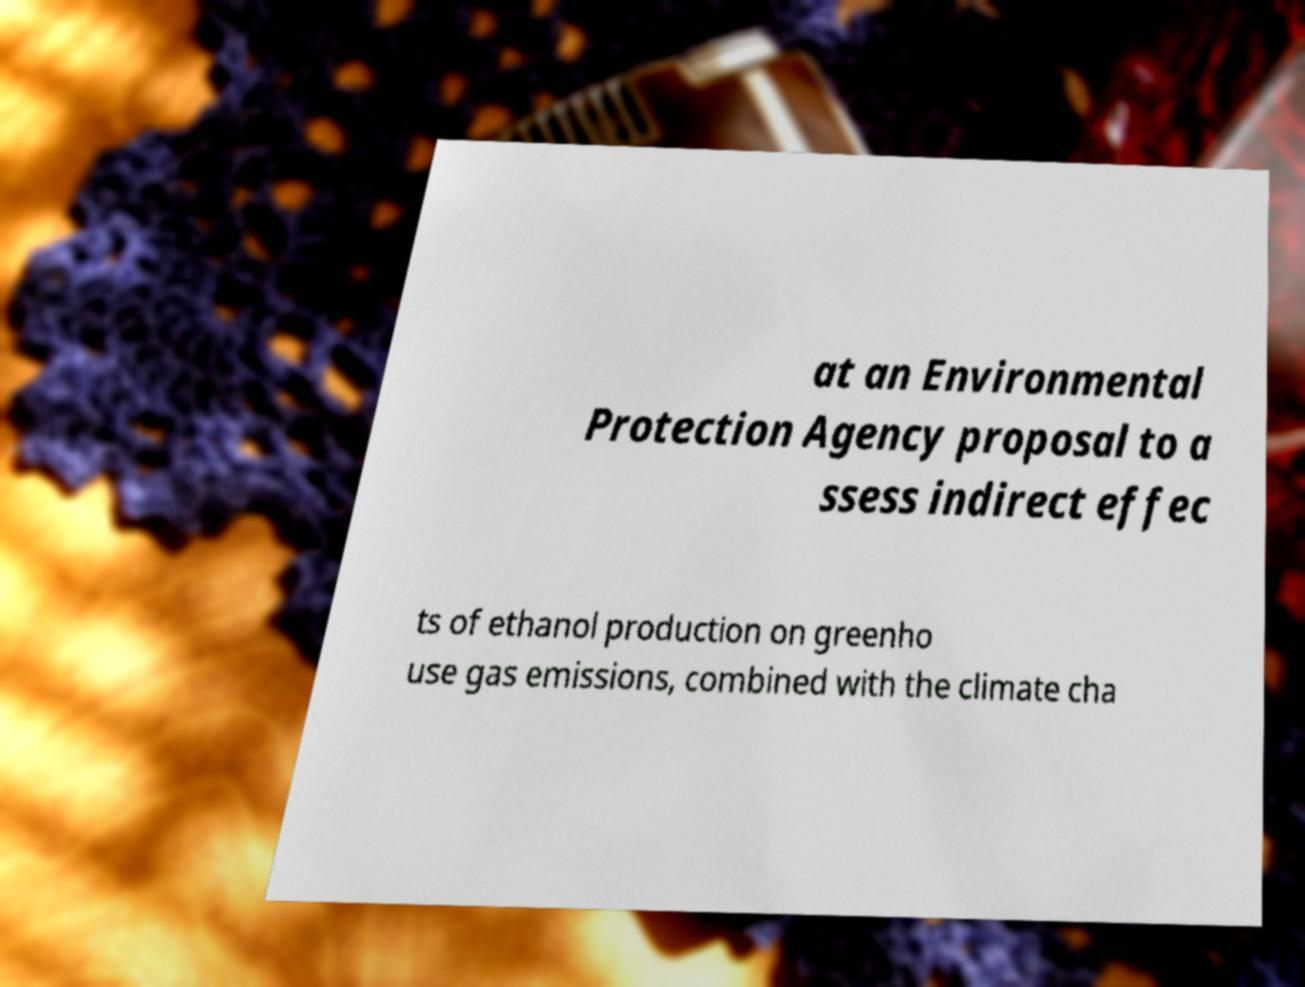What messages or text are displayed in this image? I need them in a readable, typed format. at an Environmental Protection Agency proposal to a ssess indirect effec ts of ethanol production on greenho use gas emissions, combined with the climate cha 